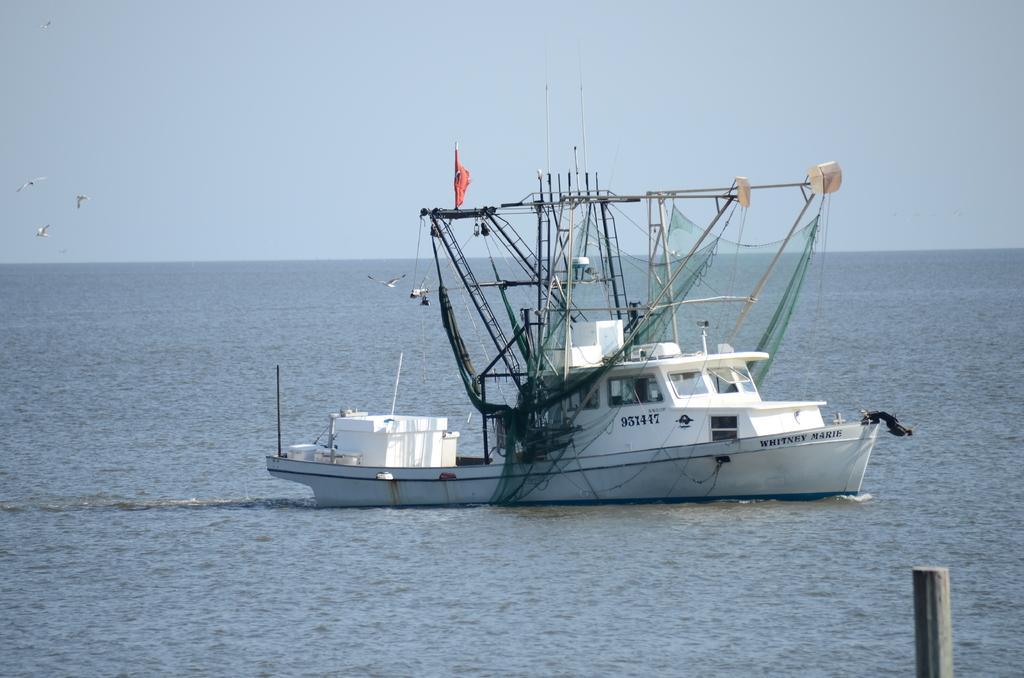Describe this image in one or two sentences. In this picture there is a water body. In the center of the picture there is a ship. On the right there is a wooden pole. In the background towards left there are birds flying and there is sky. 